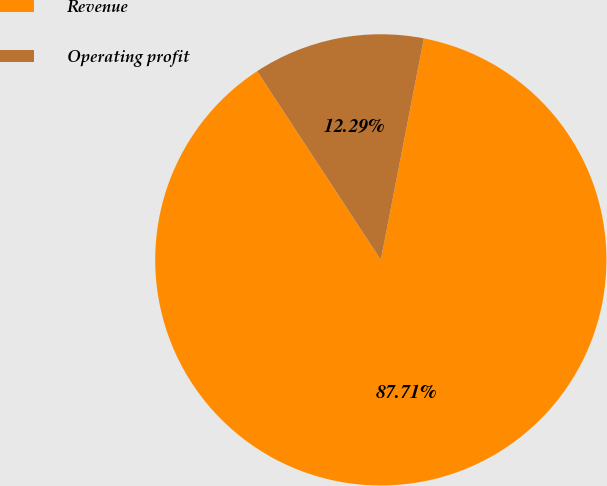<chart> <loc_0><loc_0><loc_500><loc_500><pie_chart><fcel>Revenue<fcel>Operating profit<nl><fcel>87.71%<fcel>12.29%<nl></chart> 